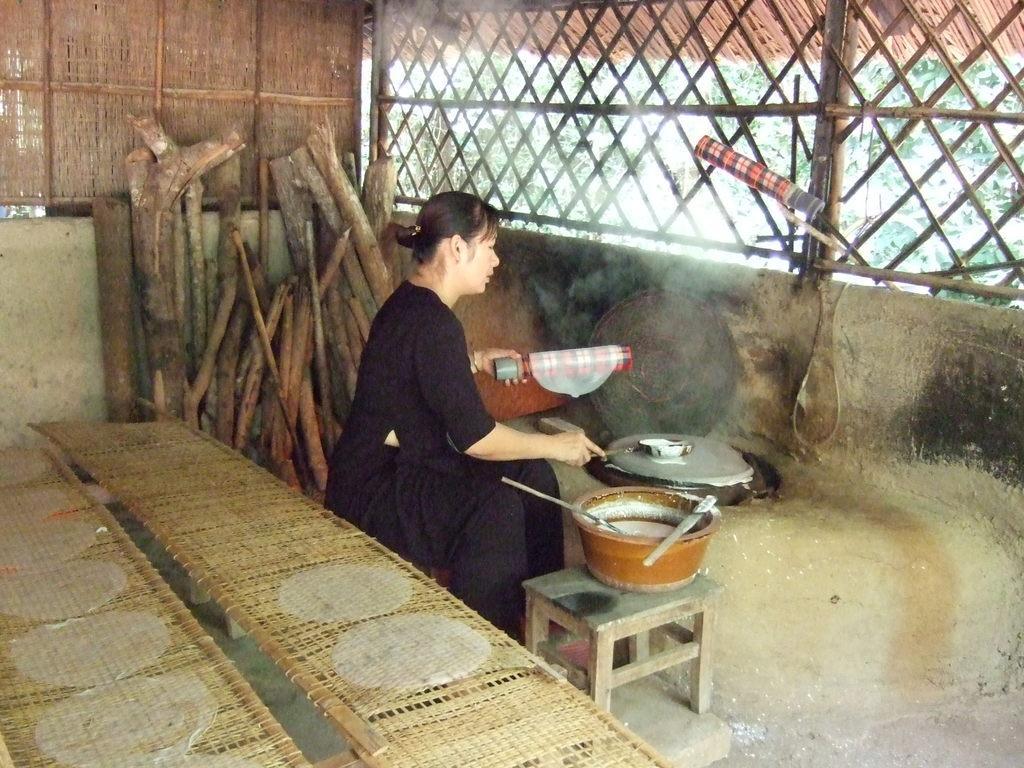Can you describe this image briefly? In this image I can see a woman wearing a black color dress and sitting on the stool. It seems like he's preparing some food item. At the back of her there is a table. In the background there are some sticks. 